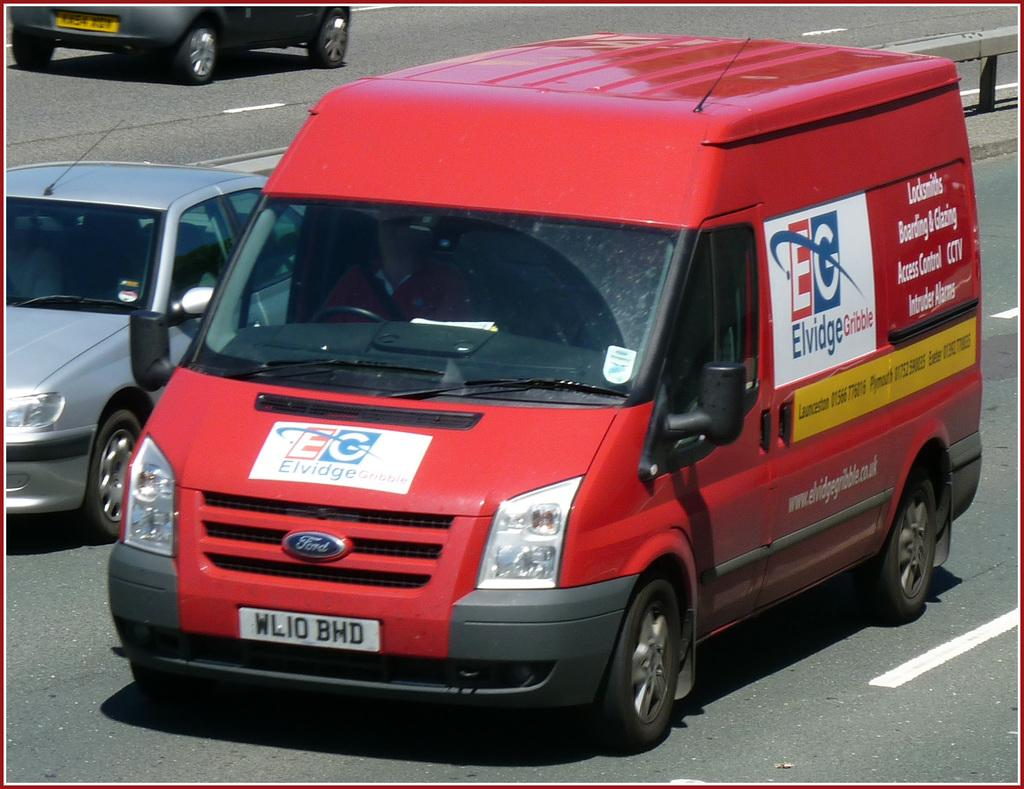<image>
Write a terse but informative summary of the picture. A red Ford van with a tag that says WLIO BHD. 